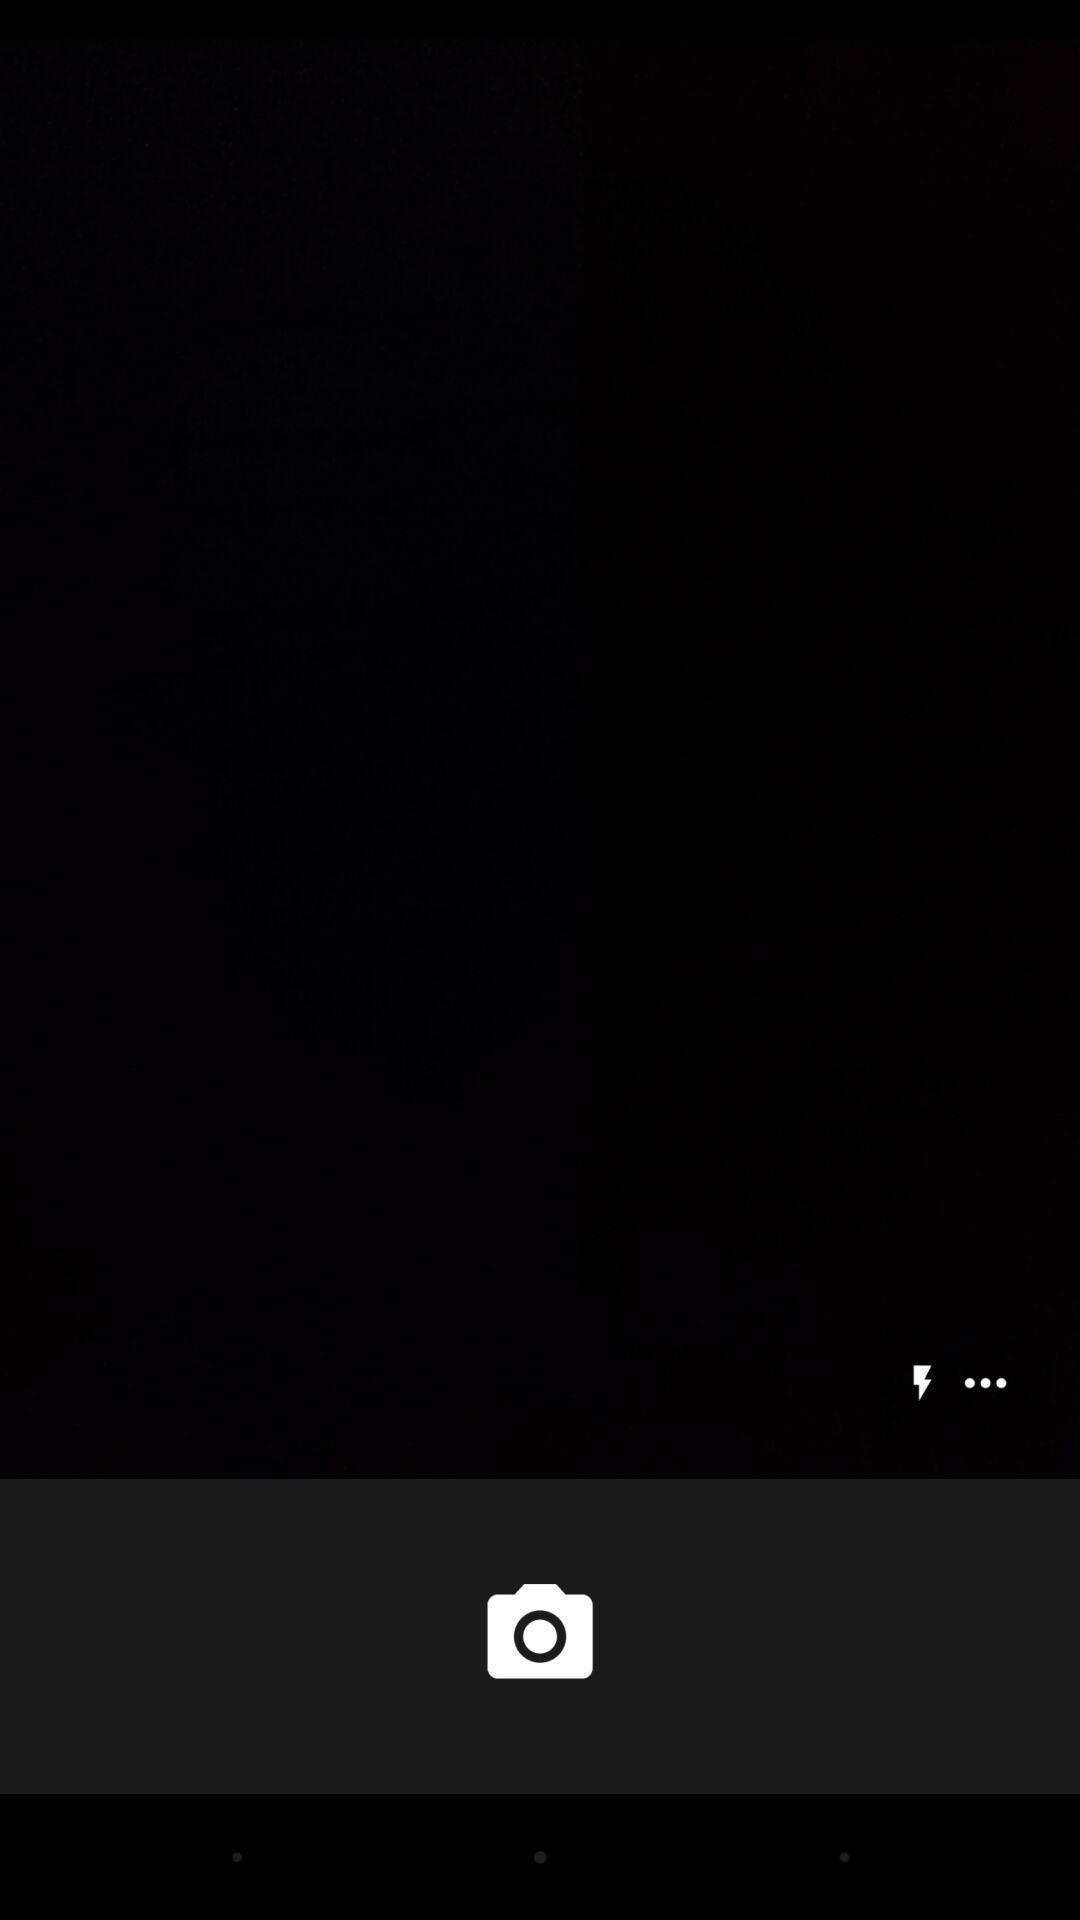Summarize the information in this screenshot. Page showing the camera icon. 